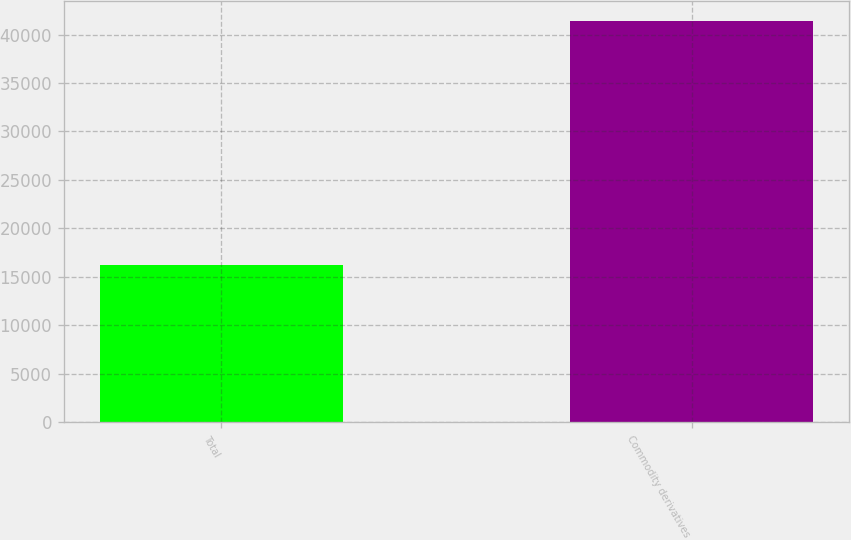Convert chart. <chart><loc_0><loc_0><loc_500><loc_500><bar_chart><fcel>Total<fcel>Commodity derivatives<nl><fcel>16245<fcel>41351<nl></chart> 